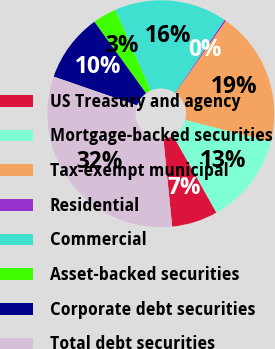Convert chart to OTSL. <chart><loc_0><loc_0><loc_500><loc_500><pie_chart><fcel>US Treasury and agency<fcel>Mortgage-backed securities<fcel>Tax-exempt municipal<fcel>Residential<fcel>Commercial<fcel>Asset-backed securities<fcel>Corporate debt securities<fcel>Total debt securities<nl><fcel>6.56%<fcel>12.9%<fcel>19.23%<fcel>0.23%<fcel>16.06%<fcel>3.39%<fcel>9.73%<fcel>31.9%<nl></chart> 